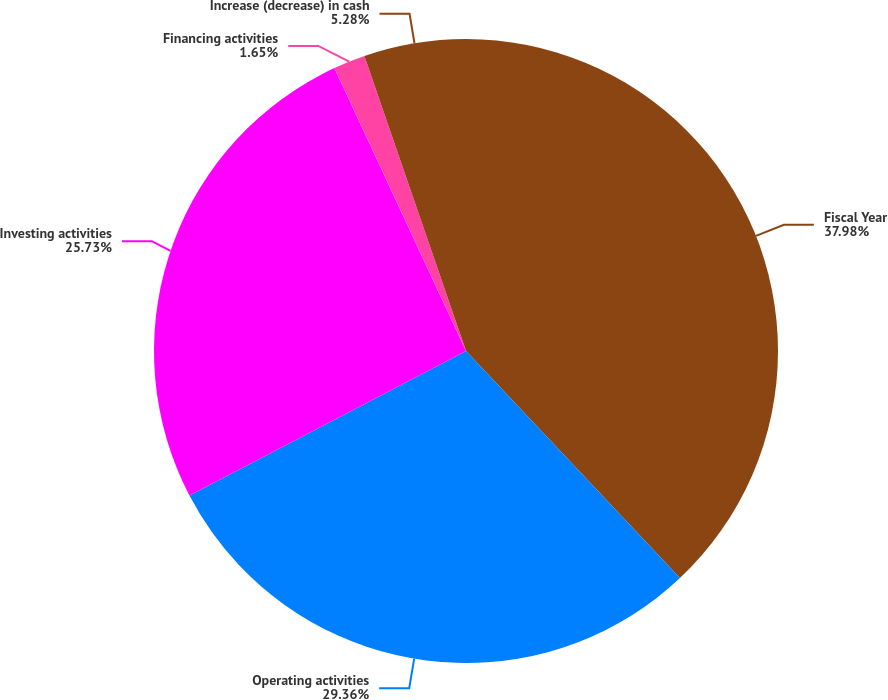Convert chart to OTSL. <chart><loc_0><loc_0><loc_500><loc_500><pie_chart><fcel>Fiscal Year<fcel>Operating activities<fcel>Investing activities<fcel>Financing activities<fcel>Increase (decrease) in cash<nl><fcel>37.97%<fcel>29.36%<fcel>25.73%<fcel>1.65%<fcel>5.28%<nl></chart> 